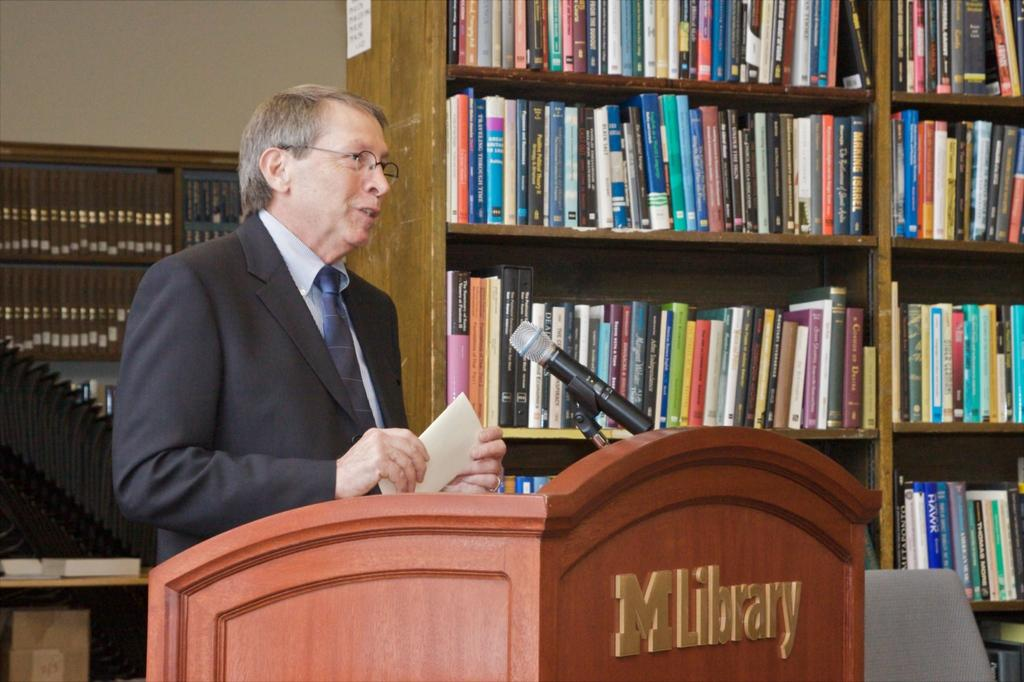<image>
Provide a brief description of the given image. A man at a lecturn which has MLibrary on it. 